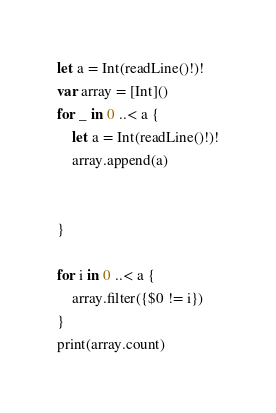Convert code to text. <code><loc_0><loc_0><loc_500><loc_500><_Swift_>let a = Int(readLine()!)!
var array = [Int]()
for _ in 0 ..< a {
    let a = Int(readLine()!)!
    array.append(a)
    
    
}

for i in 0 ..< a {
    array.filter({$0 != i})
}
print(array.count)
</code> 